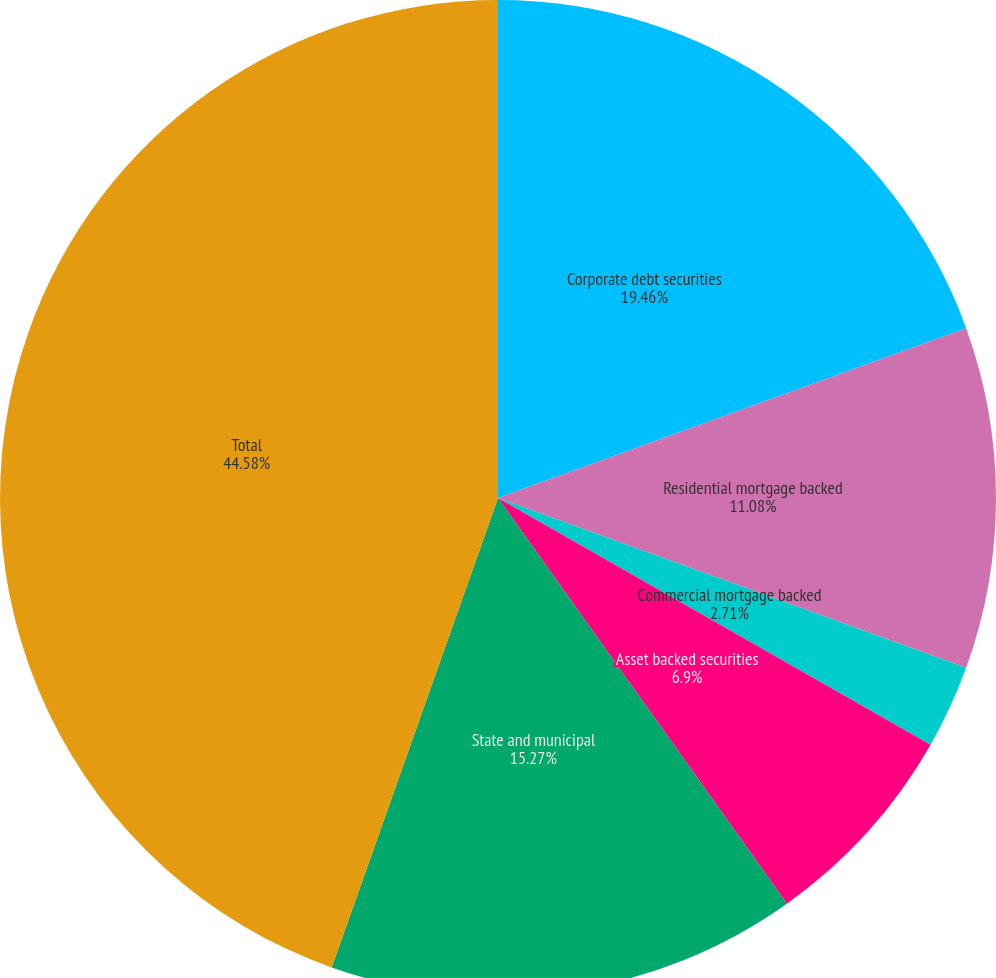Convert chart to OTSL. <chart><loc_0><loc_0><loc_500><loc_500><pie_chart><fcel>Corporate debt securities<fcel>Residential mortgage backed<fcel>Commercial mortgage backed<fcel>Asset backed securities<fcel>State and municipal<fcel>Total<nl><fcel>19.46%<fcel>11.08%<fcel>2.71%<fcel>6.9%<fcel>15.27%<fcel>44.58%<nl></chart> 